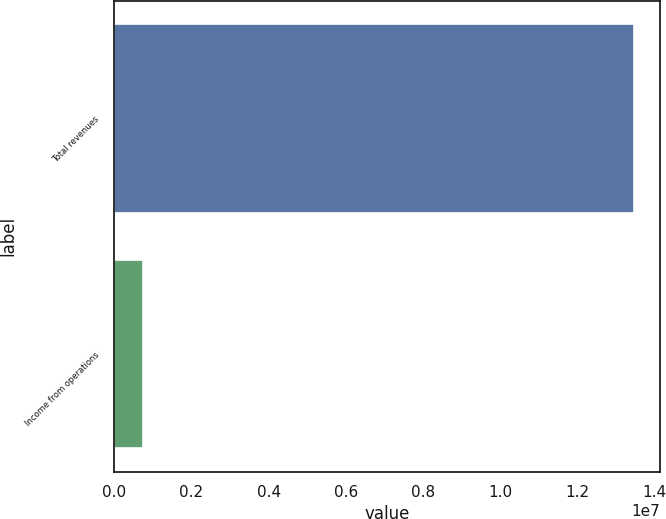Convert chart. <chart><loc_0><loc_0><loc_500><loc_500><bar_chart><fcel>Total revenues<fcel>Income from operations<nl><fcel>1.34701e+07<fcel>748418<nl></chart> 